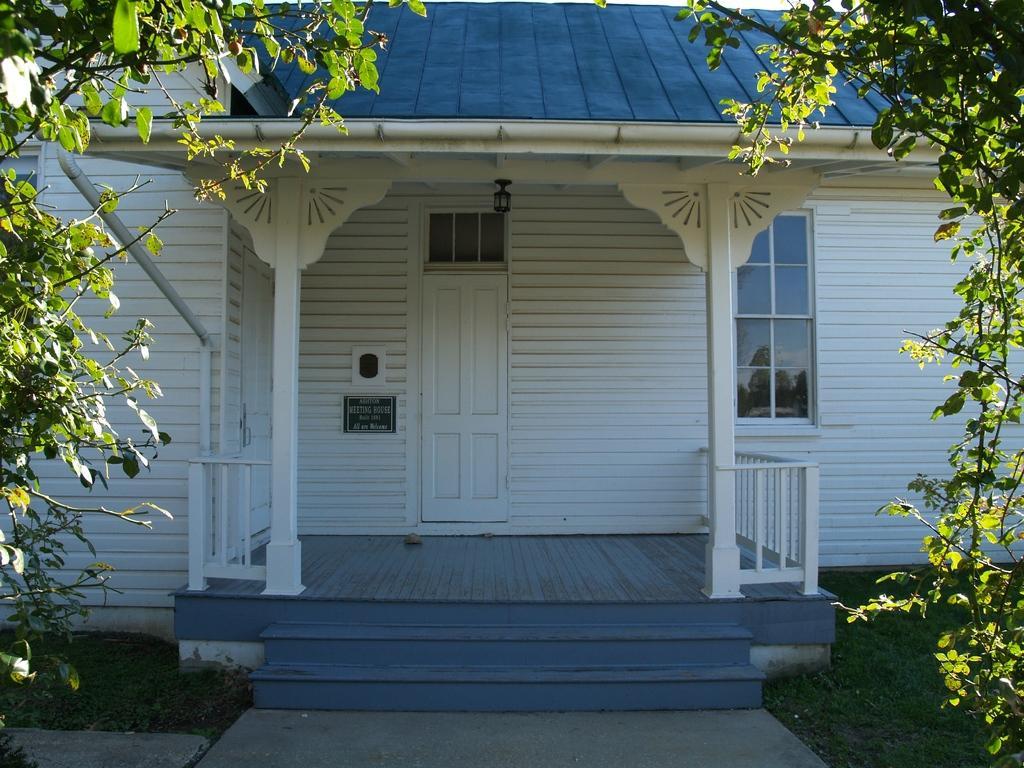Please provide a concise description of this image. In this image there is a house. There are windows, doors and a ventilator to the house. There is a name board to the wall of the house. There is a railing. There is grass on the ground. On the either sides of the image there are leaves of trees. 